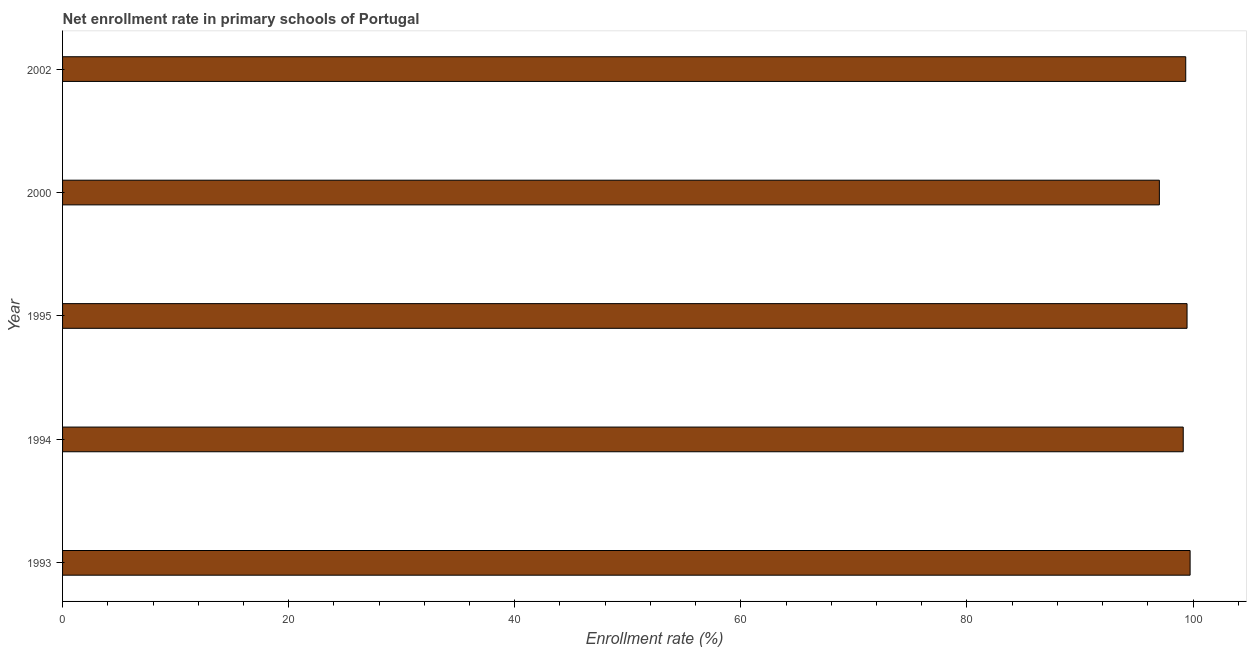Does the graph contain grids?
Ensure brevity in your answer.  No. What is the title of the graph?
Provide a short and direct response. Net enrollment rate in primary schools of Portugal. What is the label or title of the X-axis?
Offer a terse response. Enrollment rate (%). What is the net enrollment rate in primary schools in 1993?
Your answer should be very brief. 99.74. Across all years, what is the maximum net enrollment rate in primary schools?
Your answer should be very brief. 99.74. Across all years, what is the minimum net enrollment rate in primary schools?
Your response must be concise. 97.02. What is the sum of the net enrollment rate in primary schools?
Provide a succinct answer. 494.72. What is the difference between the net enrollment rate in primary schools in 1993 and 1994?
Provide a short and direct response. 0.61. What is the average net enrollment rate in primary schools per year?
Provide a succinct answer. 98.94. What is the median net enrollment rate in primary schools?
Provide a succinct answer. 99.35. In how many years, is the net enrollment rate in primary schools greater than 68 %?
Ensure brevity in your answer.  5. Do a majority of the years between 1993 and 1995 (inclusive) have net enrollment rate in primary schools greater than 36 %?
Provide a short and direct response. Yes. What is the ratio of the net enrollment rate in primary schools in 1994 to that in 2002?
Your answer should be compact. 1. Is the net enrollment rate in primary schools in 1994 less than that in 2002?
Make the answer very short. Yes. What is the difference between the highest and the second highest net enrollment rate in primary schools?
Ensure brevity in your answer.  0.27. What is the difference between the highest and the lowest net enrollment rate in primary schools?
Give a very brief answer. 2.72. In how many years, is the net enrollment rate in primary schools greater than the average net enrollment rate in primary schools taken over all years?
Ensure brevity in your answer.  4. How many years are there in the graph?
Your answer should be compact. 5. What is the Enrollment rate (%) in 1993?
Your answer should be compact. 99.74. What is the Enrollment rate (%) of 1994?
Your response must be concise. 99.13. What is the Enrollment rate (%) of 1995?
Offer a terse response. 99.47. What is the Enrollment rate (%) of 2000?
Your answer should be compact. 97.02. What is the Enrollment rate (%) in 2002?
Keep it short and to the point. 99.35. What is the difference between the Enrollment rate (%) in 1993 and 1994?
Your answer should be compact. 0.61. What is the difference between the Enrollment rate (%) in 1993 and 1995?
Your answer should be compact. 0.27. What is the difference between the Enrollment rate (%) in 1993 and 2000?
Your response must be concise. 2.72. What is the difference between the Enrollment rate (%) in 1993 and 2002?
Make the answer very short. 0.39. What is the difference between the Enrollment rate (%) in 1994 and 1995?
Offer a terse response. -0.34. What is the difference between the Enrollment rate (%) in 1994 and 2000?
Your answer should be very brief. 2.11. What is the difference between the Enrollment rate (%) in 1994 and 2002?
Offer a very short reply. -0.22. What is the difference between the Enrollment rate (%) in 1995 and 2000?
Keep it short and to the point. 2.45. What is the difference between the Enrollment rate (%) in 1995 and 2002?
Make the answer very short. 0.12. What is the difference between the Enrollment rate (%) in 2000 and 2002?
Give a very brief answer. -2.33. What is the ratio of the Enrollment rate (%) in 1993 to that in 1994?
Provide a succinct answer. 1.01. What is the ratio of the Enrollment rate (%) in 1993 to that in 1995?
Your response must be concise. 1. What is the ratio of the Enrollment rate (%) in 1993 to that in 2000?
Provide a succinct answer. 1.03. What is the ratio of the Enrollment rate (%) in 1993 to that in 2002?
Provide a succinct answer. 1. What is the ratio of the Enrollment rate (%) in 1994 to that in 1995?
Offer a terse response. 1. What is the ratio of the Enrollment rate (%) in 1995 to that in 2000?
Your answer should be compact. 1.02. What is the ratio of the Enrollment rate (%) in 1995 to that in 2002?
Ensure brevity in your answer.  1. 